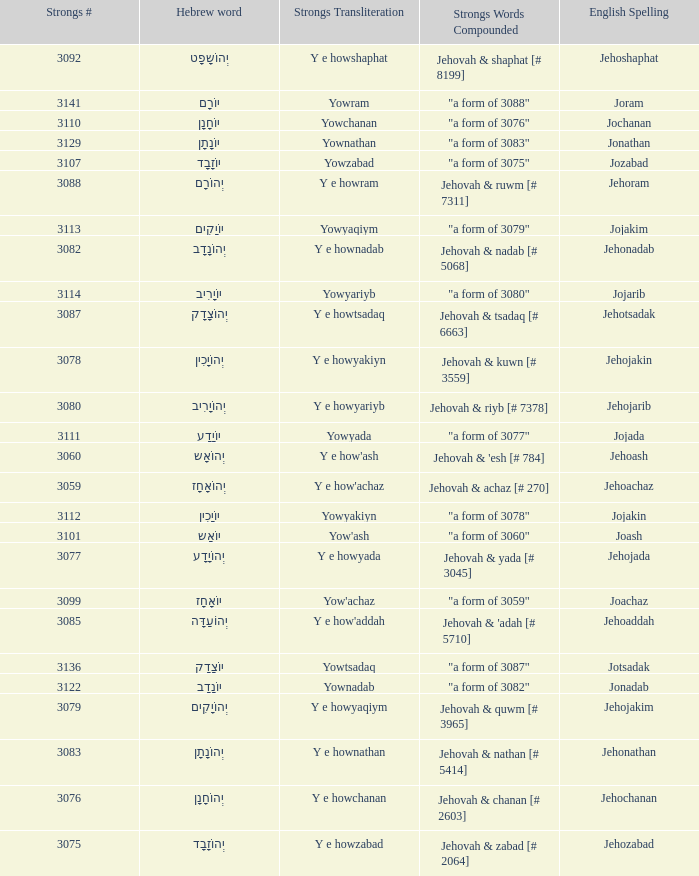What is the strongs transliteration of the hebrew word יוֹחָנָן? Yowchanan. 